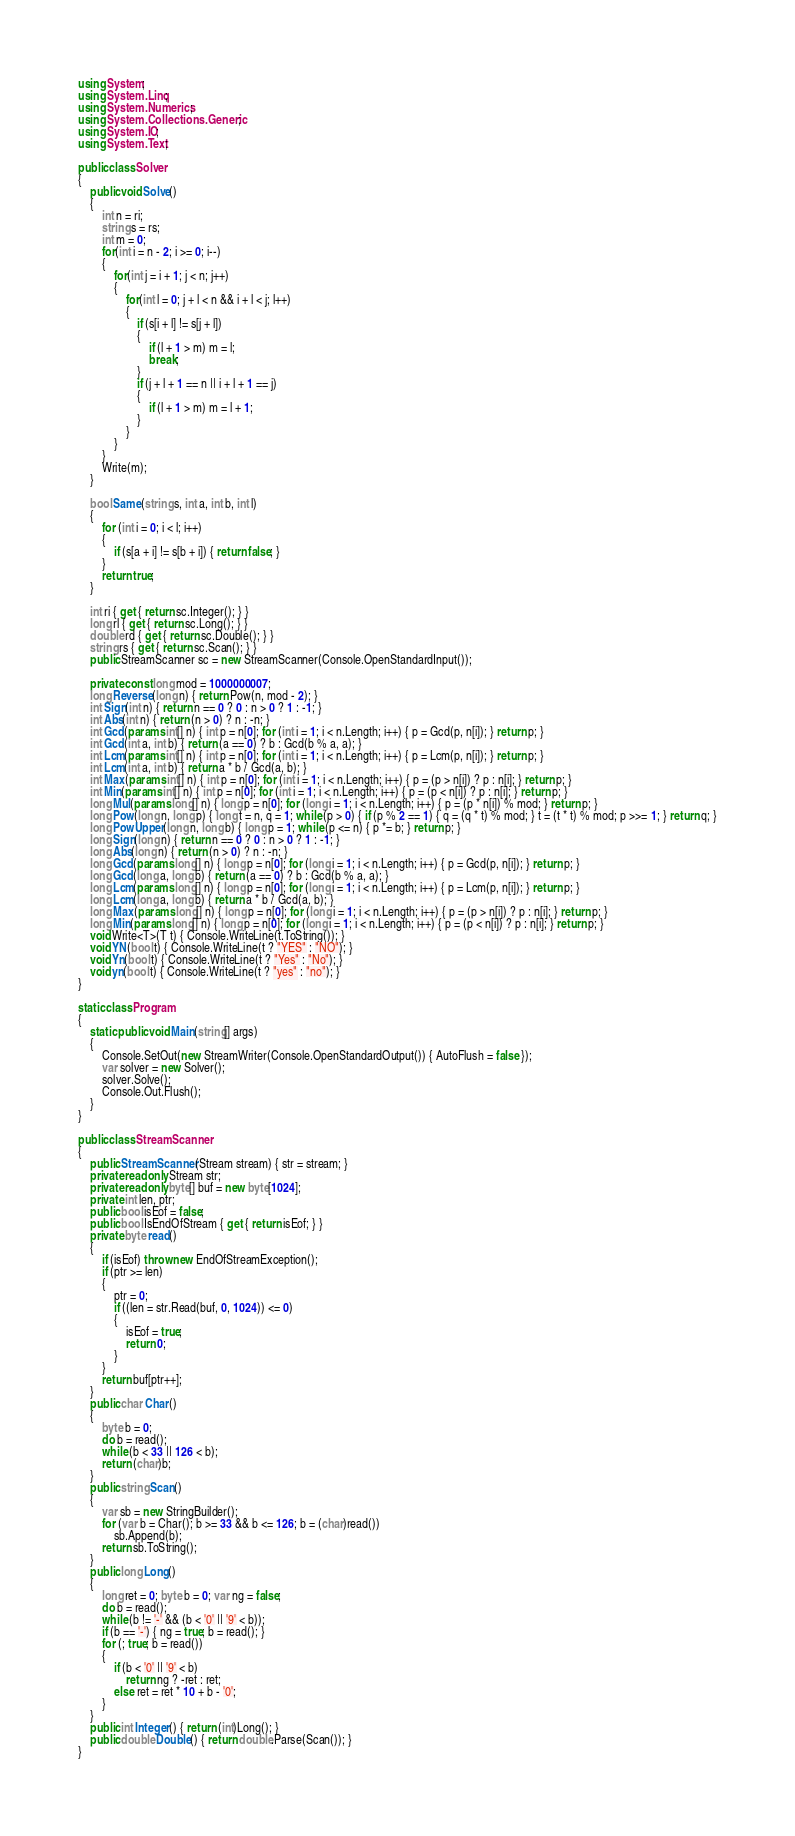<code> <loc_0><loc_0><loc_500><loc_500><_C#_>using System;
using System.Linq;
using System.Numerics;
using System.Collections.Generic;
using System.IO;
using System.Text;

public class Solver
{
    public void Solve()
    {
        int n = ri;
        string s = rs;
        int m = 0;
        for(int i = n - 2; i >= 0; i--)
        {
            for(int j = i + 1; j < n; j++)
            {
                for(int l = 0; j + l < n && i + l < j; l++)
                {
                    if (s[i + l] != s[j + l])
                    {
                        if (l + 1 > m) m = l;
                        break;
                    }
                    if (j + l + 1 == n || i + l + 1 == j)
                    {
                        if (l + 1 > m) m = l + 1;
                    }
                }
            }
        }
        Write(m);
    }

    bool Same(string s, int a, int b, int l)
    {
        for (int i = 0; i < l; i++)
        {
            if (s[a + i] != s[b + i]) { return false; }
        }
        return true;
    }

    int ri { get { return sc.Integer(); } }
    long rl { get { return sc.Long(); } }
    double rd { get { return sc.Double(); } }
    string rs { get { return sc.Scan(); } }
    public StreamScanner sc = new StreamScanner(Console.OpenStandardInput());

    private const long mod = 1000000007;
    long Reverse(long n) { return Pow(n, mod - 2); }
    int Sign(int n) { return n == 0 ? 0 : n > 0 ? 1 : -1; }
    int Abs(int n) { return (n > 0) ? n : -n; }
    int Gcd(params int[] n) { int p = n[0]; for (int i = 1; i < n.Length; i++) { p = Gcd(p, n[i]); } return p; }
    int Gcd(int a, int b) { return (a == 0) ? b : Gcd(b % a, a); }
    int Lcm(params int[] n) { int p = n[0]; for (int i = 1; i < n.Length; i++) { p = Lcm(p, n[i]); } return p; }
    int Lcm(int a, int b) { return a * b / Gcd(a, b); }
    int Max(params int[] n) { int p = n[0]; for (int i = 1; i < n.Length; i++) { p = (p > n[i]) ? p : n[i]; } return p; }
    int Min(params int[] n) { int p = n[0]; for (int i = 1; i < n.Length; i++) { p = (p < n[i]) ? p : n[i]; } return p; }
    long Mul(params long[] n) { long p = n[0]; for (long i = 1; i < n.Length; i++) { p = (p * n[i]) % mod; } return p; }
    long Pow(long n, long p) { long t = n, q = 1; while (p > 0) { if (p % 2 == 1) { q = (q * t) % mod; } t = (t * t) % mod; p >>= 1; } return q; }
    long PowUpper(long n, long b) { long p = 1; while (p <= n) { p *= b; } return p; }
    long Sign(long n) { return n == 0 ? 0 : n > 0 ? 1 : -1; }
    long Abs(long n) { return (n > 0) ? n : -n; }
    long Gcd(params long[] n) { long p = n[0]; for (long i = 1; i < n.Length; i++) { p = Gcd(p, n[i]); } return p; }
    long Gcd(long a, long b) { return (a == 0) ? b : Gcd(b % a, a); }
    long Lcm(params long[] n) { long p = n[0]; for (long i = 1; i < n.Length; i++) { p = Lcm(p, n[i]); } return p; }
    long Lcm(long a, long b) { return a * b / Gcd(a, b); }
    long Max(params long[] n) { long p = n[0]; for (long i = 1; i < n.Length; i++) { p = (p > n[i]) ? p : n[i]; } return p; }
    long Min(params long[] n) { long p = n[0]; for (long i = 1; i < n.Length; i++) { p = (p < n[i]) ? p : n[i]; } return p; }
    void Write<T>(T t) { Console.WriteLine(t.ToString()); }
    void YN(bool t) { Console.WriteLine(t ? "YES" : "NO"); }
    void Yn(bool t) { Console.WriteLine(t ? "Yes" : "No"); }
    void yn(bool t) { Console.WriteLine(t ? "yes" : "no"); }
}

static class Program
{
    static public void Main(string[] args)
    {
        Console.SetOut(new StreamWriter(Console.OpenStandardOutput()) { AutoFlush = false });
        var solver = new Solver();
        solver.Solve();
        Console.Out.Flush();
    }
}

public class StreamScanner
{
    public StreamScanner(Stream stream) { str = stream; }
    private readonly Stream str;
    private readonly byte[] buf = new byte[1024];
    private int len, ptr;
    public bool isEof = false;
    public bool IsEndOfStream { get { return isEof; } }
    private byte read()
    {
        if (isEof) throw new EndOfStreamException();
        if (ptr >= len)
        {
            ptr = 0;
            if ((len = str.Read(buf, 0, 1024)) <= 0)
            {
                isEof = true;
                return 0;
            }
        }
        return buf[ptr++];
    }
    public char Char()
    {
        byte b = 0;
        do b = read();
        while (b < 33 || 126 < b);
        return (char)b;
    }
    public string Scan()
    {
        var sb = new StringBuilder();
        for (var b = Char(); b >= 33 && b <= 126; b = (char)read())
            sb.Append(b);
        return sb.ToString();
    }
    public long Long()
    {
        long ret = 0; byte b = 0; var ng = false;
        do b = read();
        while (b != '-' && (b < '0' || '9' < b));
        if (b == '-') { ng = true; b = read(); }
        for (; true; b = read())
        {
            if (b < '0' || '9' < b)
                return ng ? -ret : ret;
            else ret = ret * 10 + b - '0';
        }
    }
    public int Integer() { return (int)Long(); }
    public double Double() { return double.Parse(Scan()); }
}
</code> 